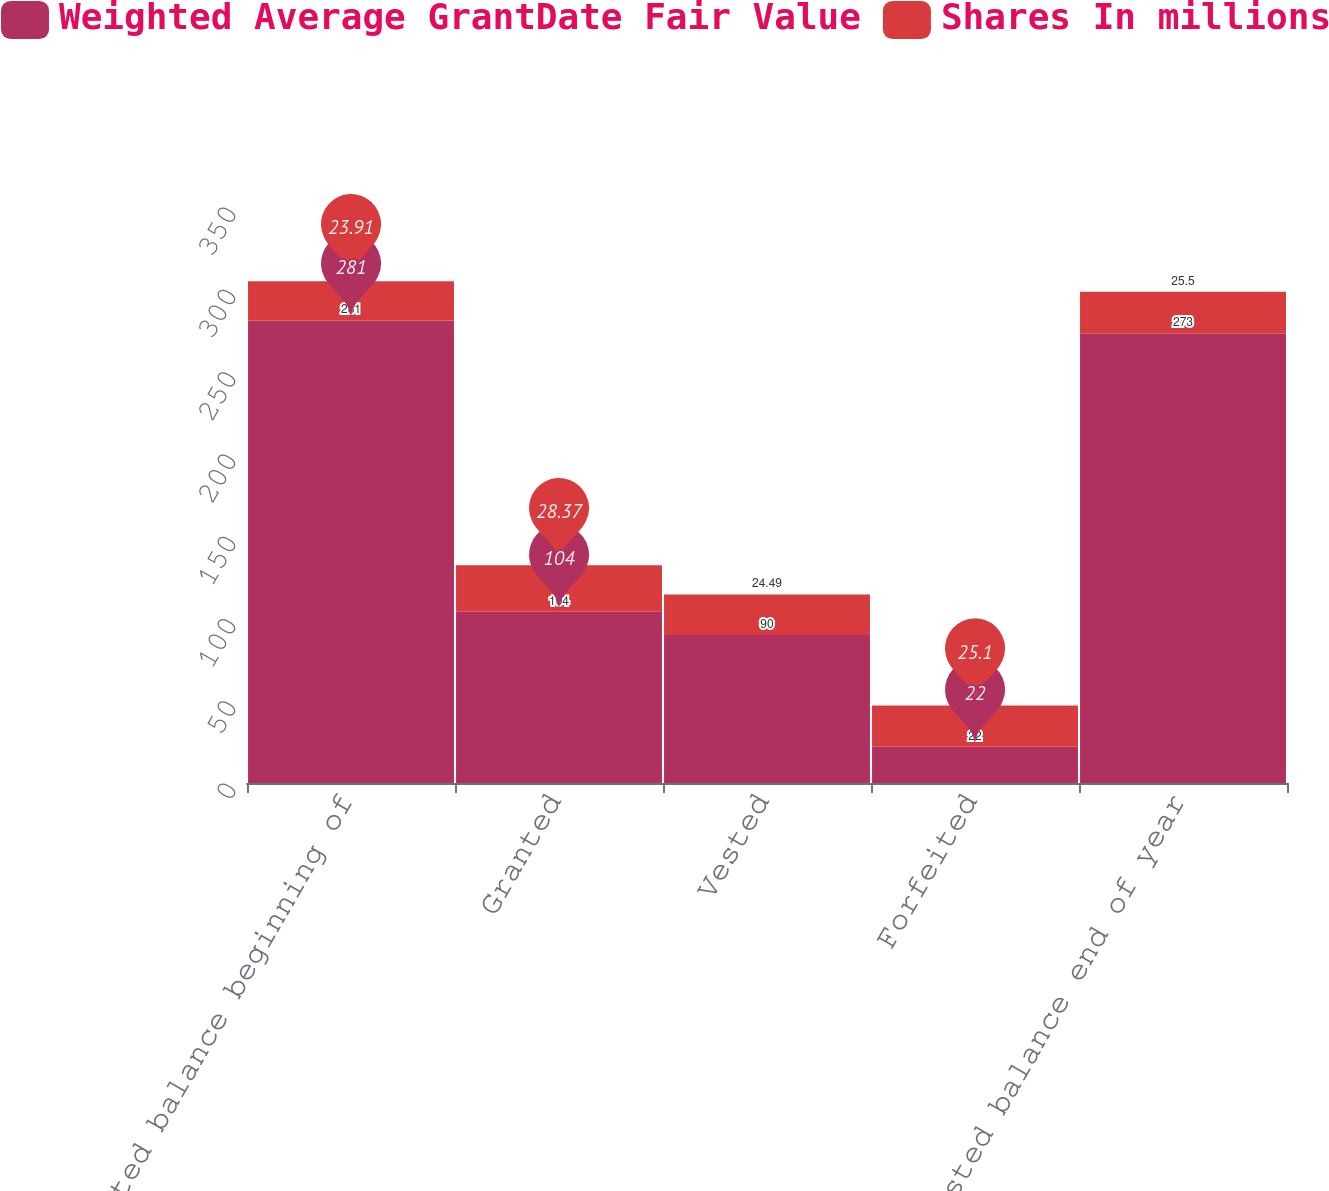Convert chart. <chart><loc_0><loc_0><loc_500><loc_500><stacked_bar_chart><ecel><fcel>Nonvested balance beginning of<fcel>Granted<fcel>Vested<fcel>Forfeited<fcel>Nonvested balance end of year<nl><fcel>Weighted Average GrantDate Fair Value<fcel>281<fcel>104<fcel>90<fcel>22<fcel>273<nl><fcel>Shares In millions<fcel>23.91<fcel>28.37<fcel>24.49<fcel>25.1<fcel>25.5<nl></chart> 